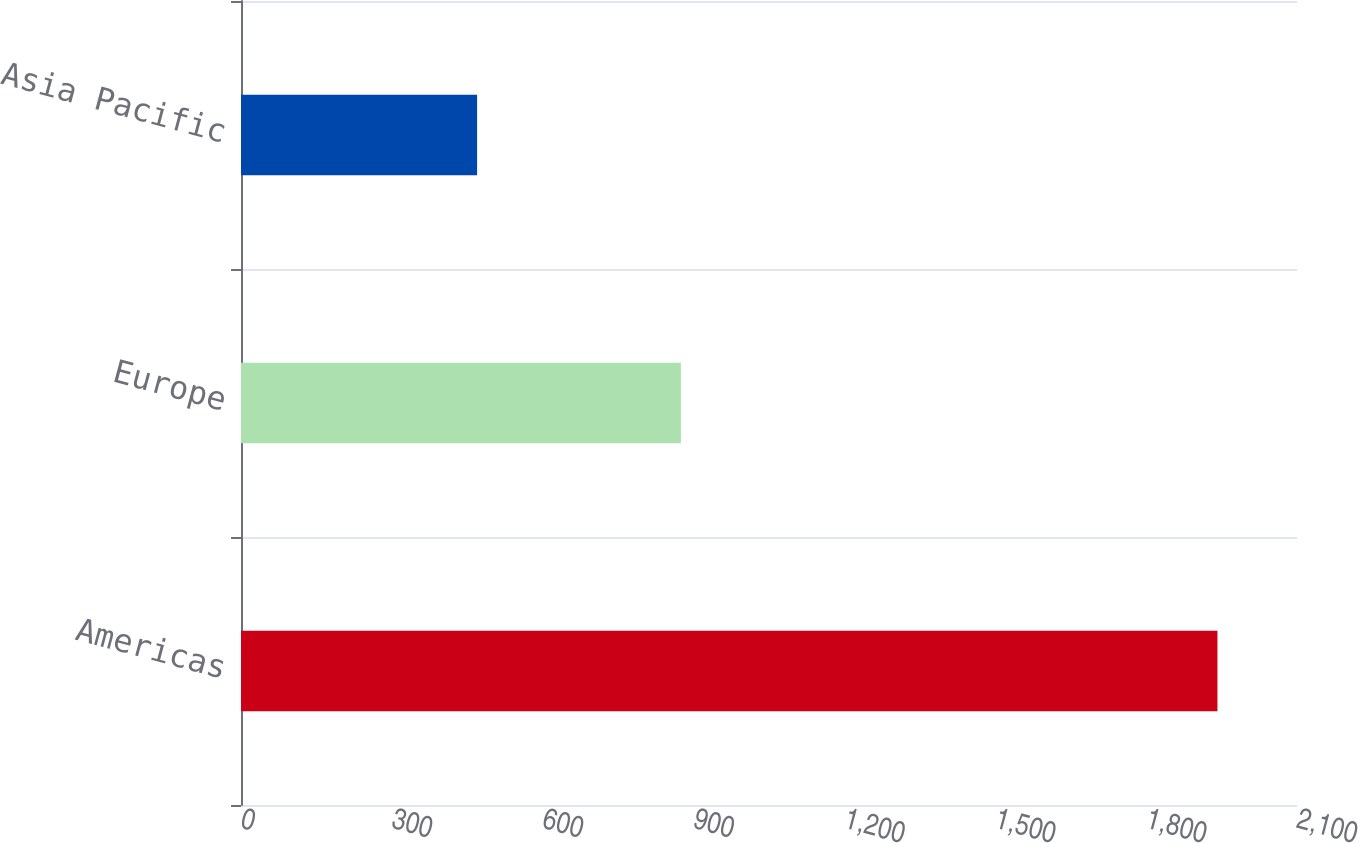<chart> <loc_0><loc_0><loc_500><loc_500><bar_chart><fcel>Americas<fcel>Europe<fcel>Asia Pacific<nl><fcel>1941.8<fcel>874.8<fcel>469.5<nl></chart> 